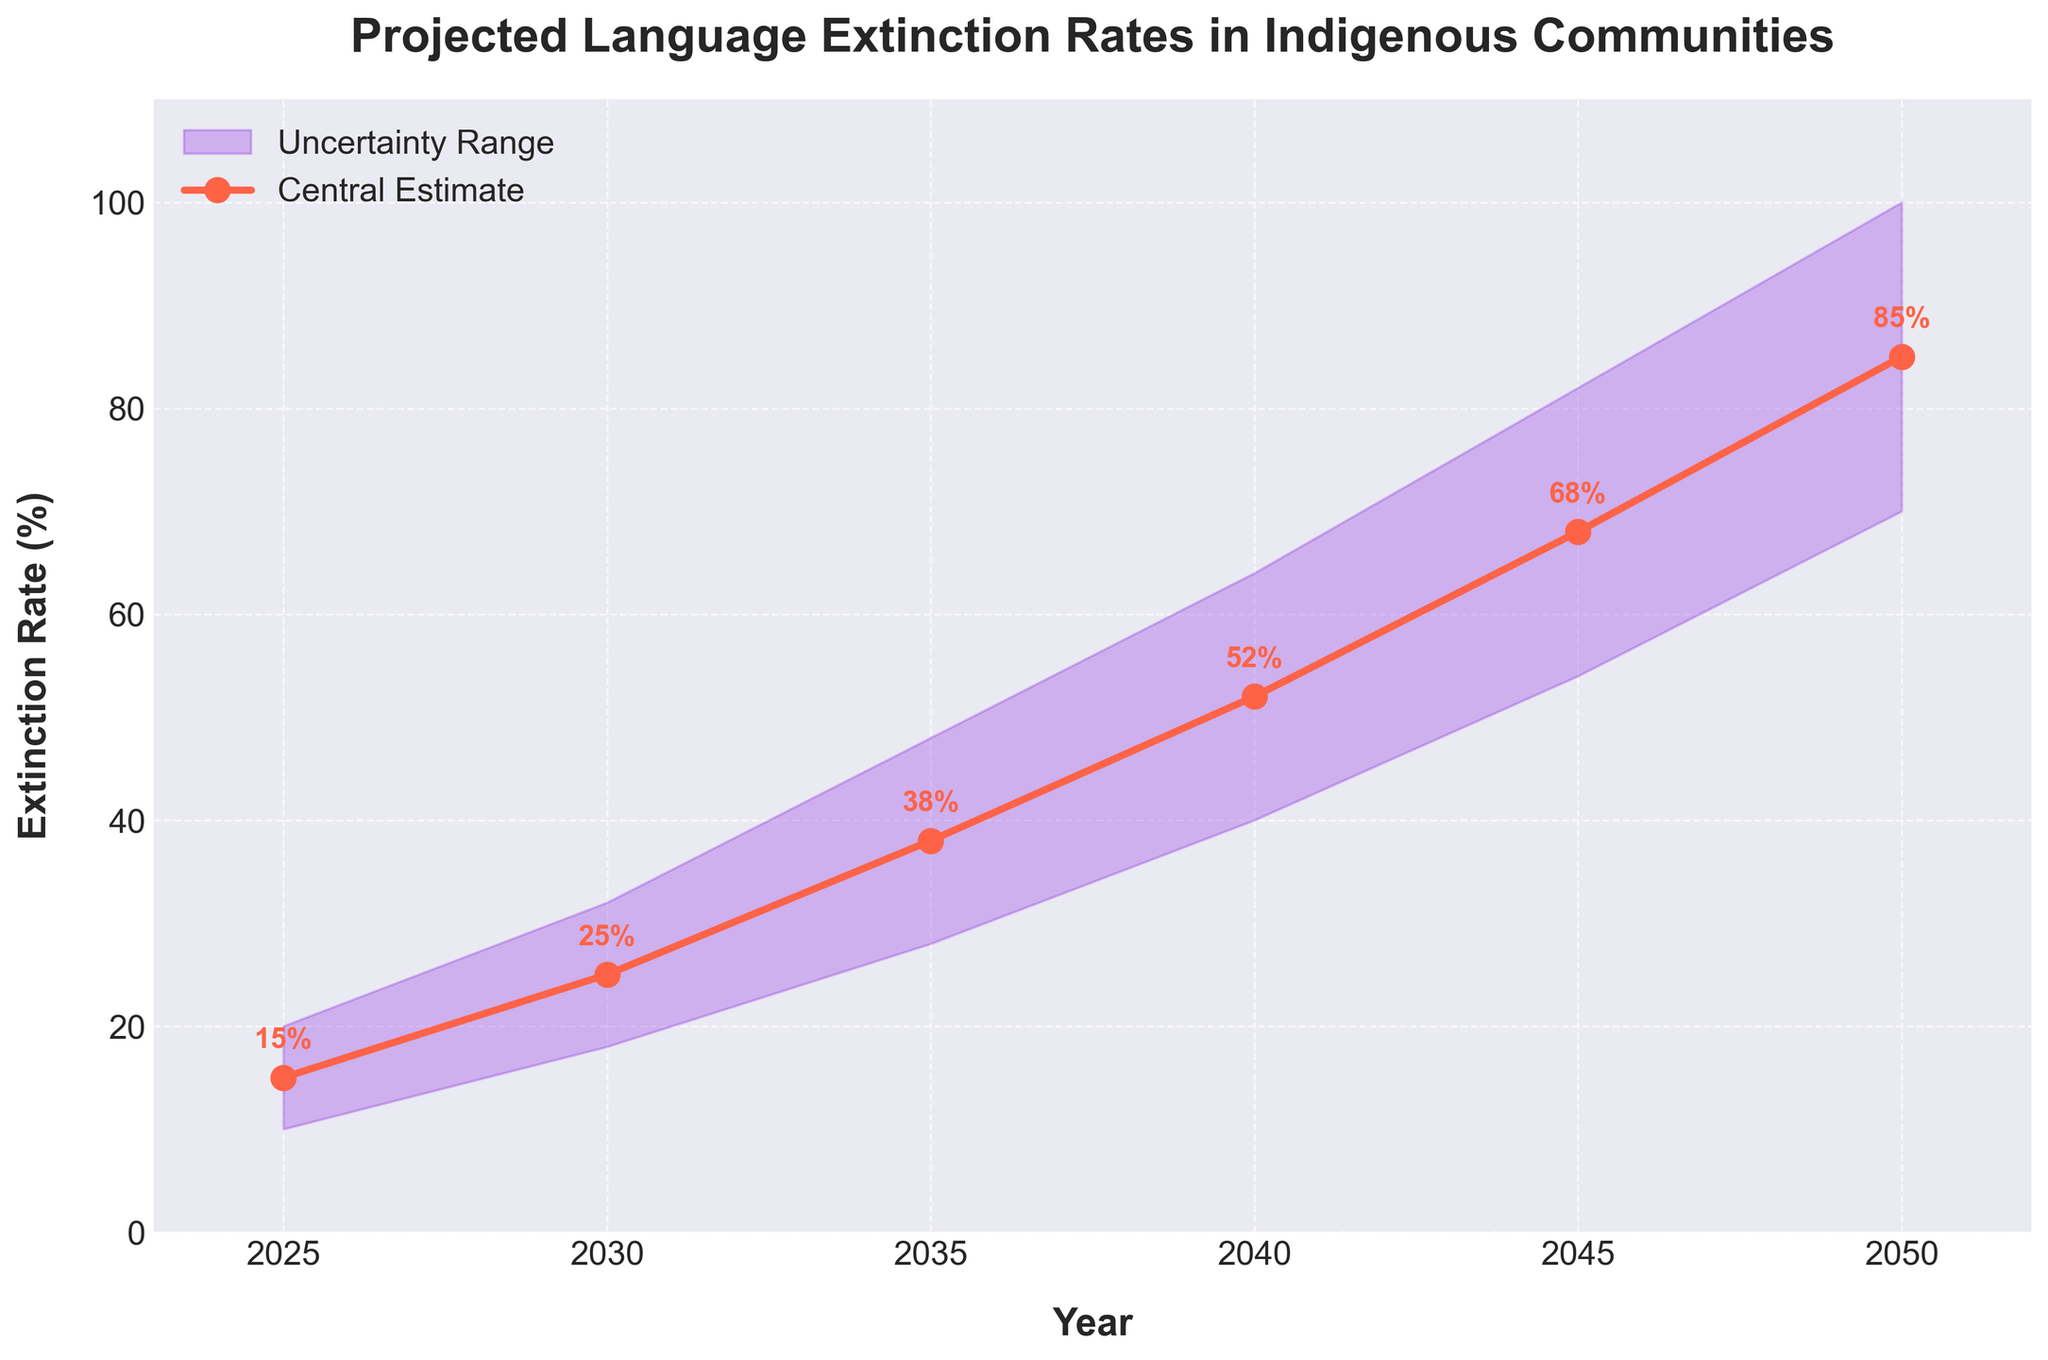what is the title of the chart? The title of the chart is written at the top of the figure. It reads "Projected Language Extinction Rates in Indigenous Communities".
Answer: Projected Language Extinction Rates in Indigenous Communities What is the extinction rate in 2025 according to the central estimate? The central estimate for the extinction rate is indicated by the data point directly above the year 2025 on the x-axis; it's also annotated on the graph.
Answer: 15% Between which years does the chart make projections? The x-axis indicates the range of years covered in the graph. The first year is 2025 and the last year is 2050.
Answer: 2025 to 2050 What is the rate of increase in the central estimate from 2025 to 2030? Find the central estimates for 2025 (15%) and 2030 (25%), then subtract the 2025 value from the 2030 value to find the rate of increase. 25 - 15 = 10
Answer: 10% How does the uncertainty range change from 2025 to 2050? Compare the lower and upper bounds of the uncertainty range at the start year (2025) and the end year (2050). The range increases as the years progress. In 2025, the range is 10% to 20%, and in 2050, it is 70% to 100%.
Answer: It increases What year has the highest central estimate? Identify the highest point on the central estimate line and note the corresponding year on the x-axis. The highest central estimate value is at the year 2050 with 85%.
Answer: 2050 By how much does the upper bound change between 2030 and 2045? Identify the upper bound for 2030 (32%) and 2045 (82%), then subtract the value for 2030 from that of 2045. 82 - 32 = 50
Answer: 50% What is the average central estimate of extinction rates for the years 2025, 2030, and 2035? Sum the central estimates for 2025 (15%), 2030 (25%), and 2035 (38%) and then divide by 3. (15+25+38)/3 = 78/3 = 26
Answer: 26% For which year is there the greatest uncertainty range? The greatest uncertainty range is determined by examining the width of the shaded area between the lower and upper bounds. The widest range occurs in 2050, with an uncertainty range of 30 (100% - 70%).
Answer: 2050 In which decade does the central estimate show the highest increase in extinction rates? Compare the increase in central estimates across decades: 2025-2035 (38% - 15% = 23%), 2035-2045 (68% - 38% = 30%), and 2045-2050 (85% - 68% = 17%). The highest increase is from 2035-2045.
Answer: 2035 to 2045 